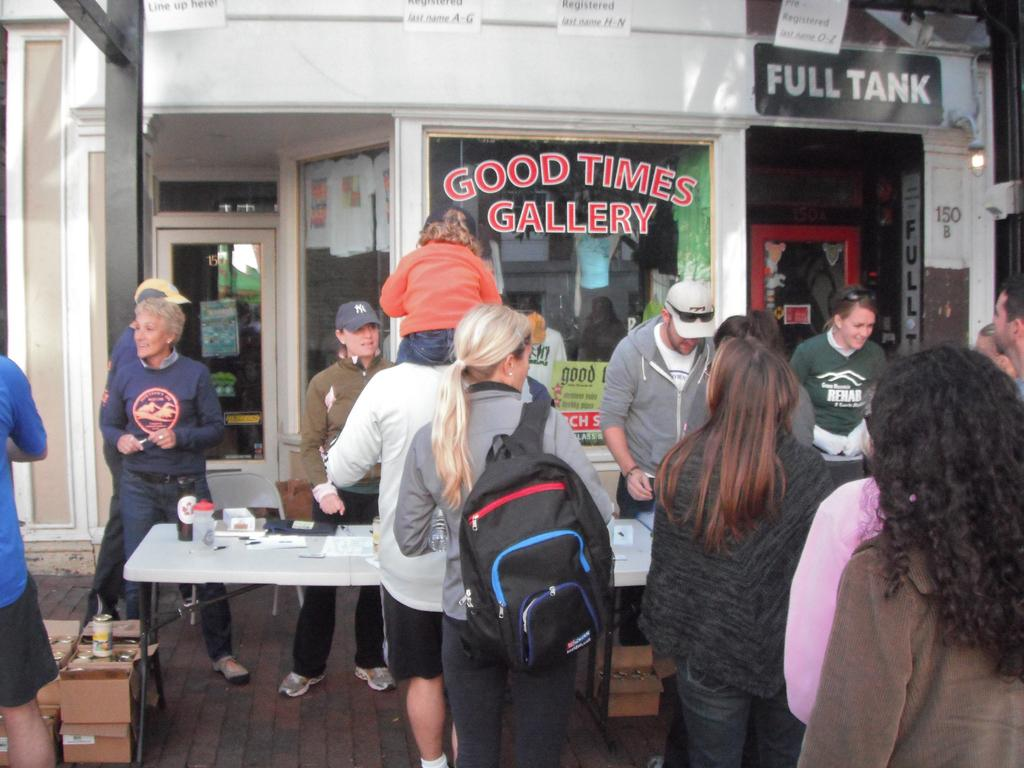How many people are in the image? There is a group of people in the image, but the exact number is not specified. What is the woman wearing in the image? The woman is wearing a bag in the image. What can be seen in the background of the image? There is a building in the background of the image. What objects are on the table in the image? There are papers on a table in the image. What type of ice can be seen melting on the church in the image? There is no ice or church present in the image. What is the chance of winning a prize in the image? There is no mention of a prize or any game of chance in the image. 